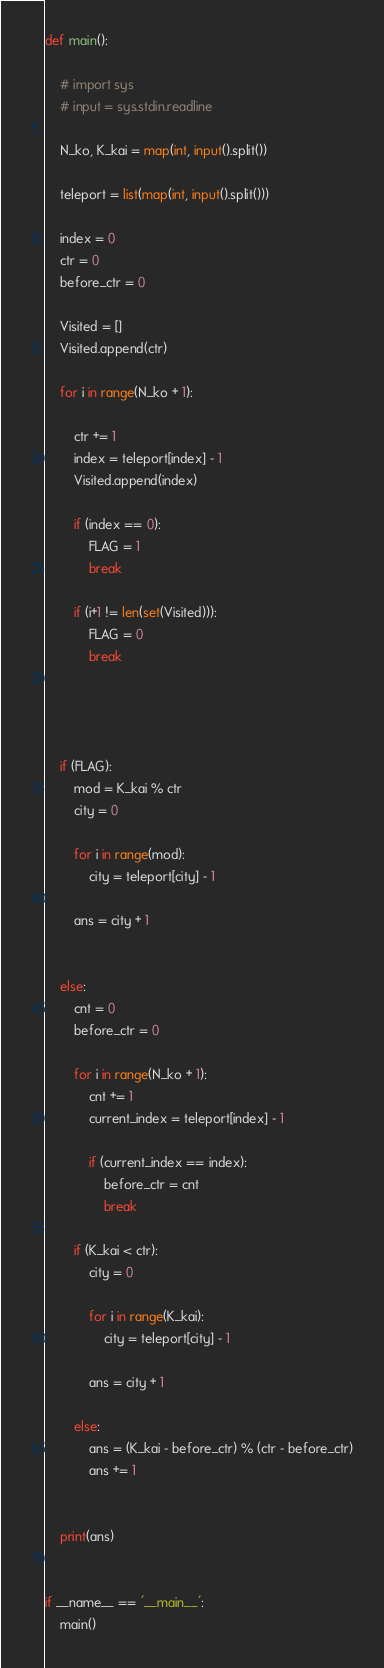<code> <loc_0><loc_0><loc_500><loc_500><_Cython_>
def main():

    # import sys
    # input = sys.stdin.readline

    N_ko, K_kai = map(int, input().split())
    
    teleport = list(map(int, input().split()))

    index = 0
    ctr = 0
    before_ctr = 0

    Visited = []
    Visited.append(ctr)

    for i in range(N_ko + 1):

        ctr += 1
        index = teleport[index] - 1
        Visited.append(index)
        
        if (index == 0):
            FLAG = 1
            break

        if (i+1 != len(set(Visited))):
            FLAG = 0
            break
    
    


    if (FLAG):
        mod = K_kai % ctr
        city = 0

        for i in range(mod):
            city = teleport[city] - 1

        ans = city + 1


    else:
        cnt = 0
        before_ctr = 0

        for i in range(N_ko + 1):
            cnt += 1
            current_index = teleport[index] - 1
            
            if (current_index == index):
                before_ctr = cnt
                break
        
        if (K_kai < ctr):
            city = 0
            
            for i in range(K_kai):
                city = teleport[city] - 1

            ans = city + 1

        else:
            ans = (K_kai - before_ctr) % (ctr - before_ctr)
            ans += 1
            

    print(ans)


if __name__ == '__main__':
    main()</code> 